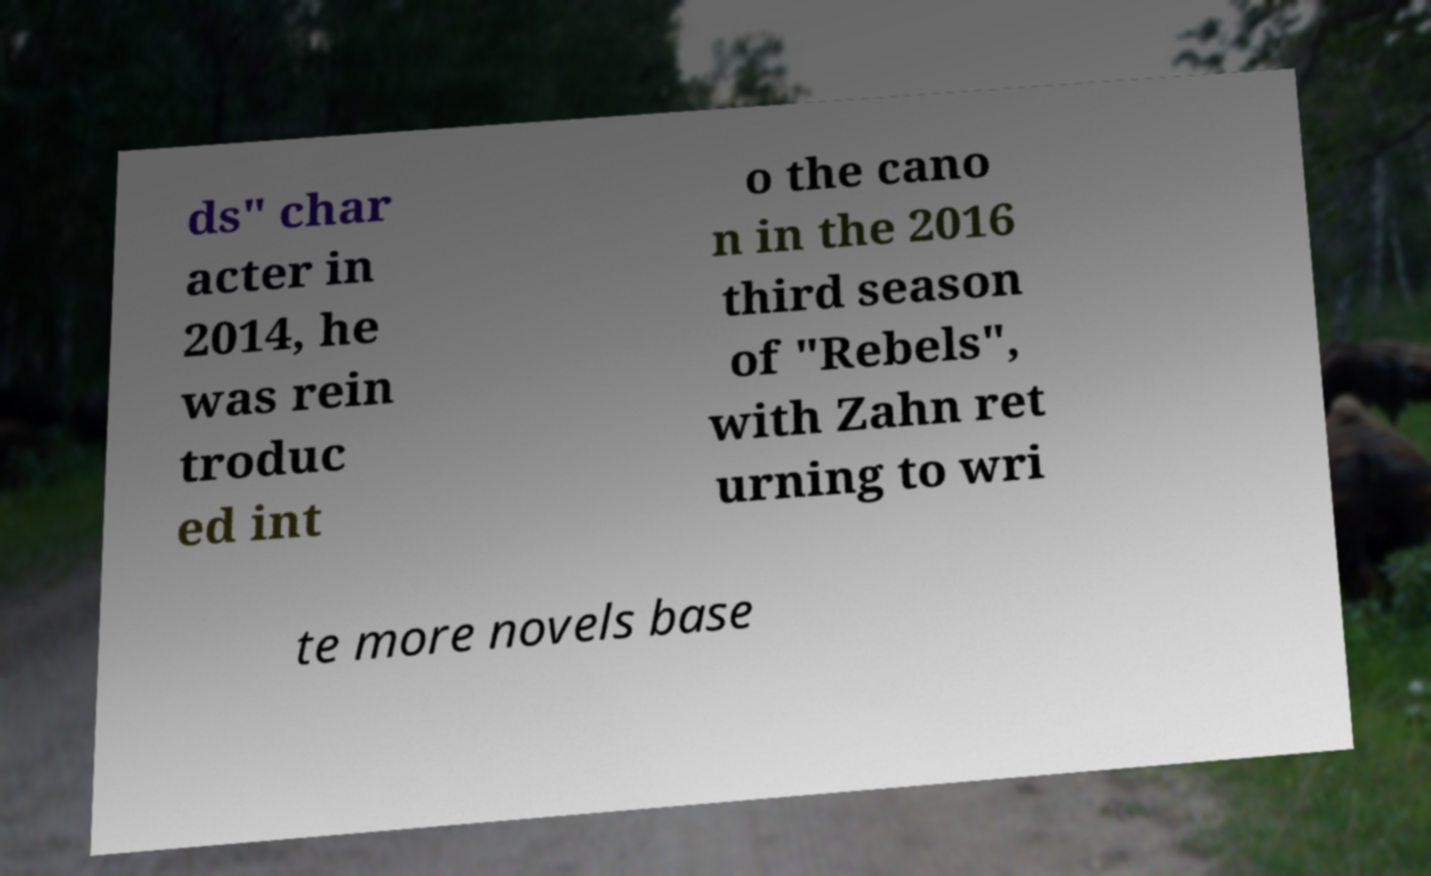Could you extract and type out the text from this image? ds" char acter in 2014, he was rein troduc ed int o the cano n in the 2016 third season of "Rebels", with Zahn ret urning to wri te more novels base 